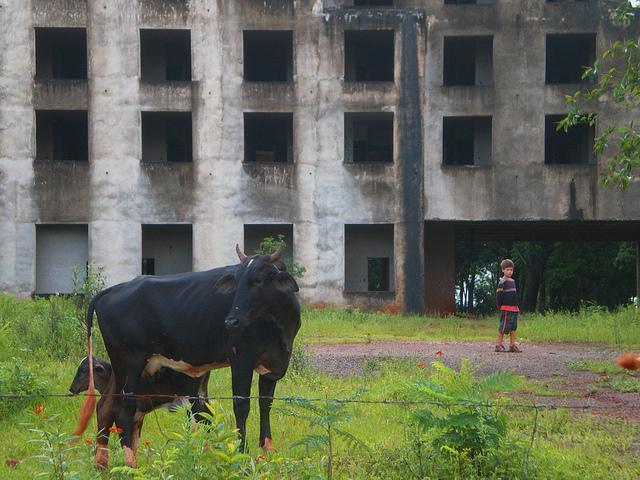How many cows are there?
Give a very brief answer. 2. How many people are using backpacks or bags?
Give a very brief answer. 0. 